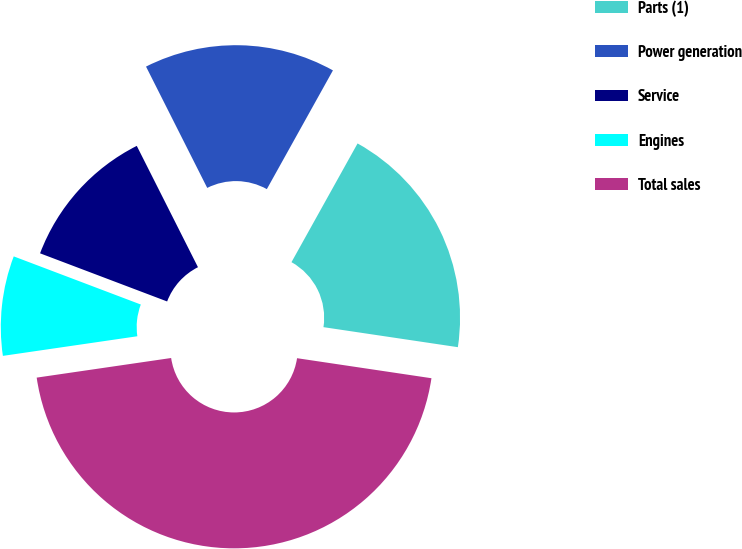Convert chart. <chart><loc_0><loc_0><loc_500><loc_500><pie_chart><fcel>Parts (1)<fcel>Power generation<fcel>Service<fcel>Engines<fcel>Total sales<nl><fcel>19.27%<fcel>15.52%<fcel>11.8%<fcel>8.07%<fcel>45.34%<nl></chart> 